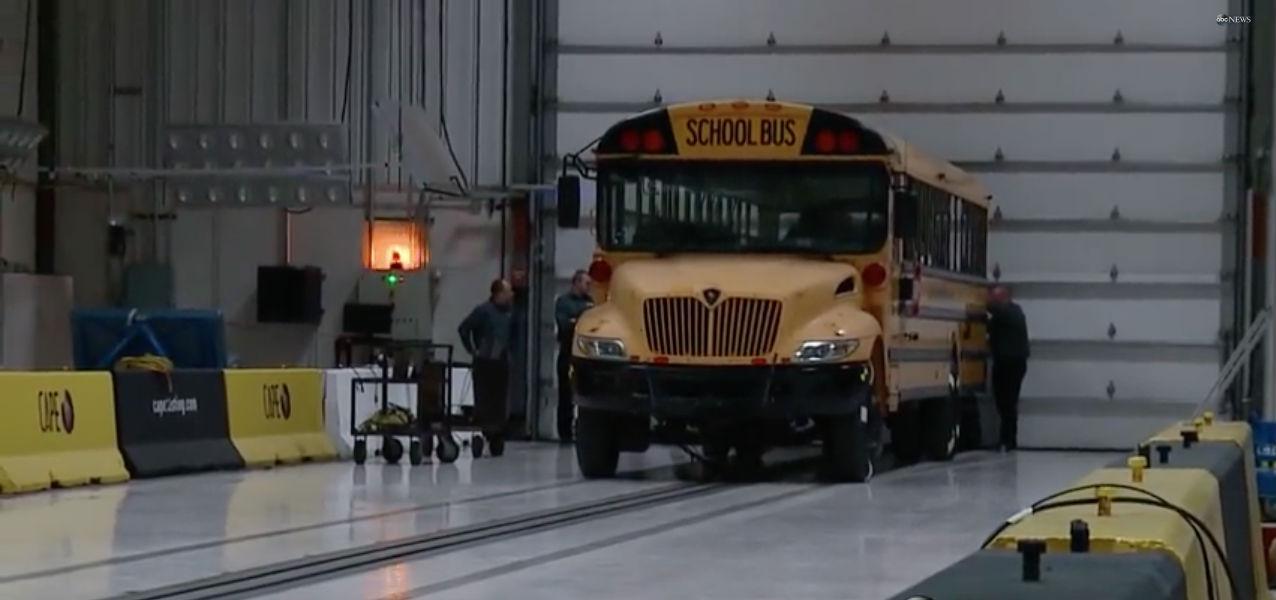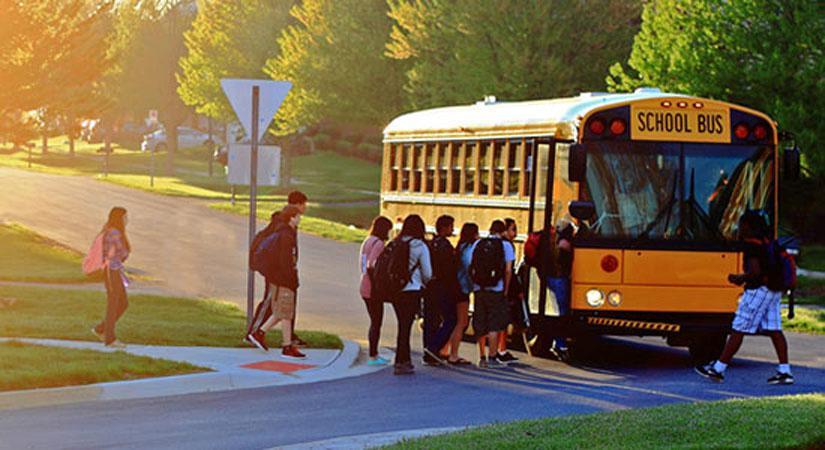The first image is the image on the left, the second image is the image on the right. Analyze the images presented: Is the assertion "There is 2 school busses shown." valid? Answer yes or no. Yes. The first image is the image on the left, the second image is the image on the right. Given the left and right images, does the statement "News headline is visible at bottom of photo for at least one image." hold true? Answer yes or no. No. 